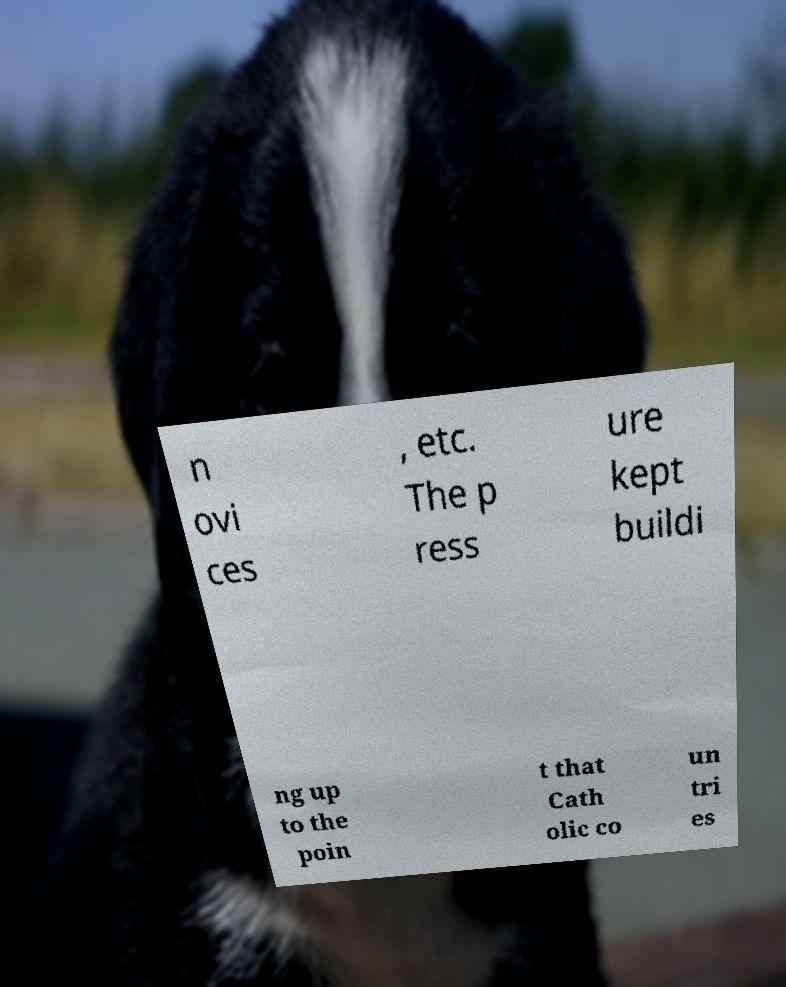Could you extract and type out the text from this image? n ovi ces , etc. The p ress ure kept buildi ng up to the poin t that Cath olic co un tri es 